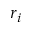<formula> <loc_0><loc_0><loc_500><loc_500>r _ { i }</formula> 